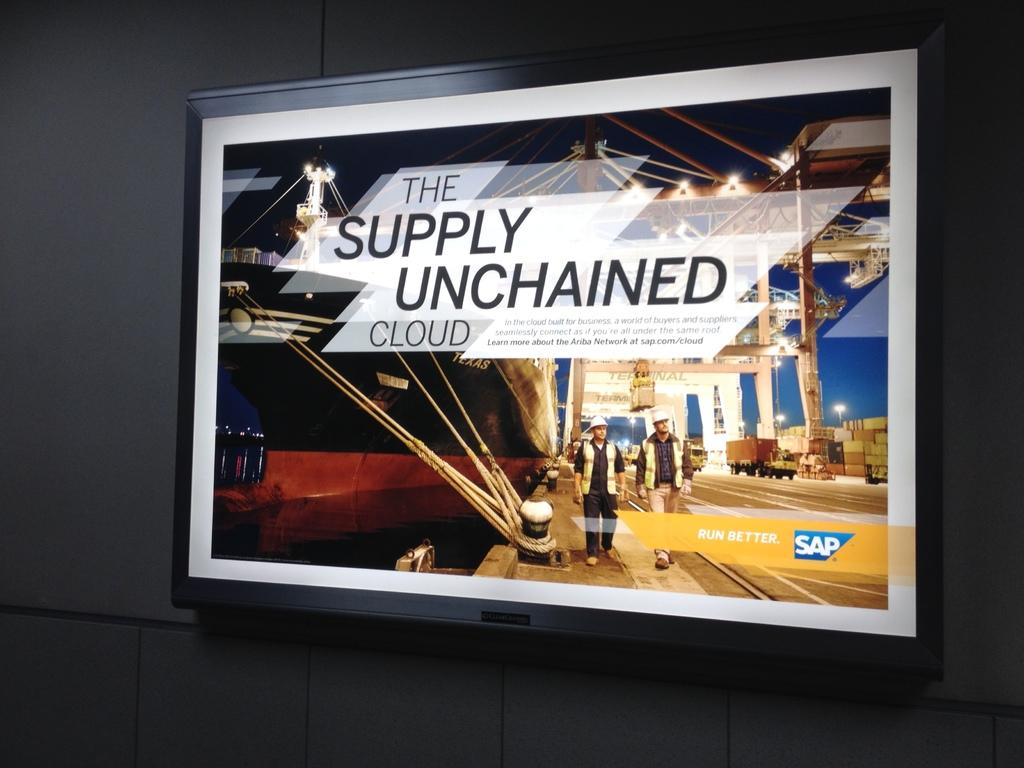Provide a one-sentence caption for the provided image. A rectangular billboard with a sign for "The Supply Unchained Cloud". 